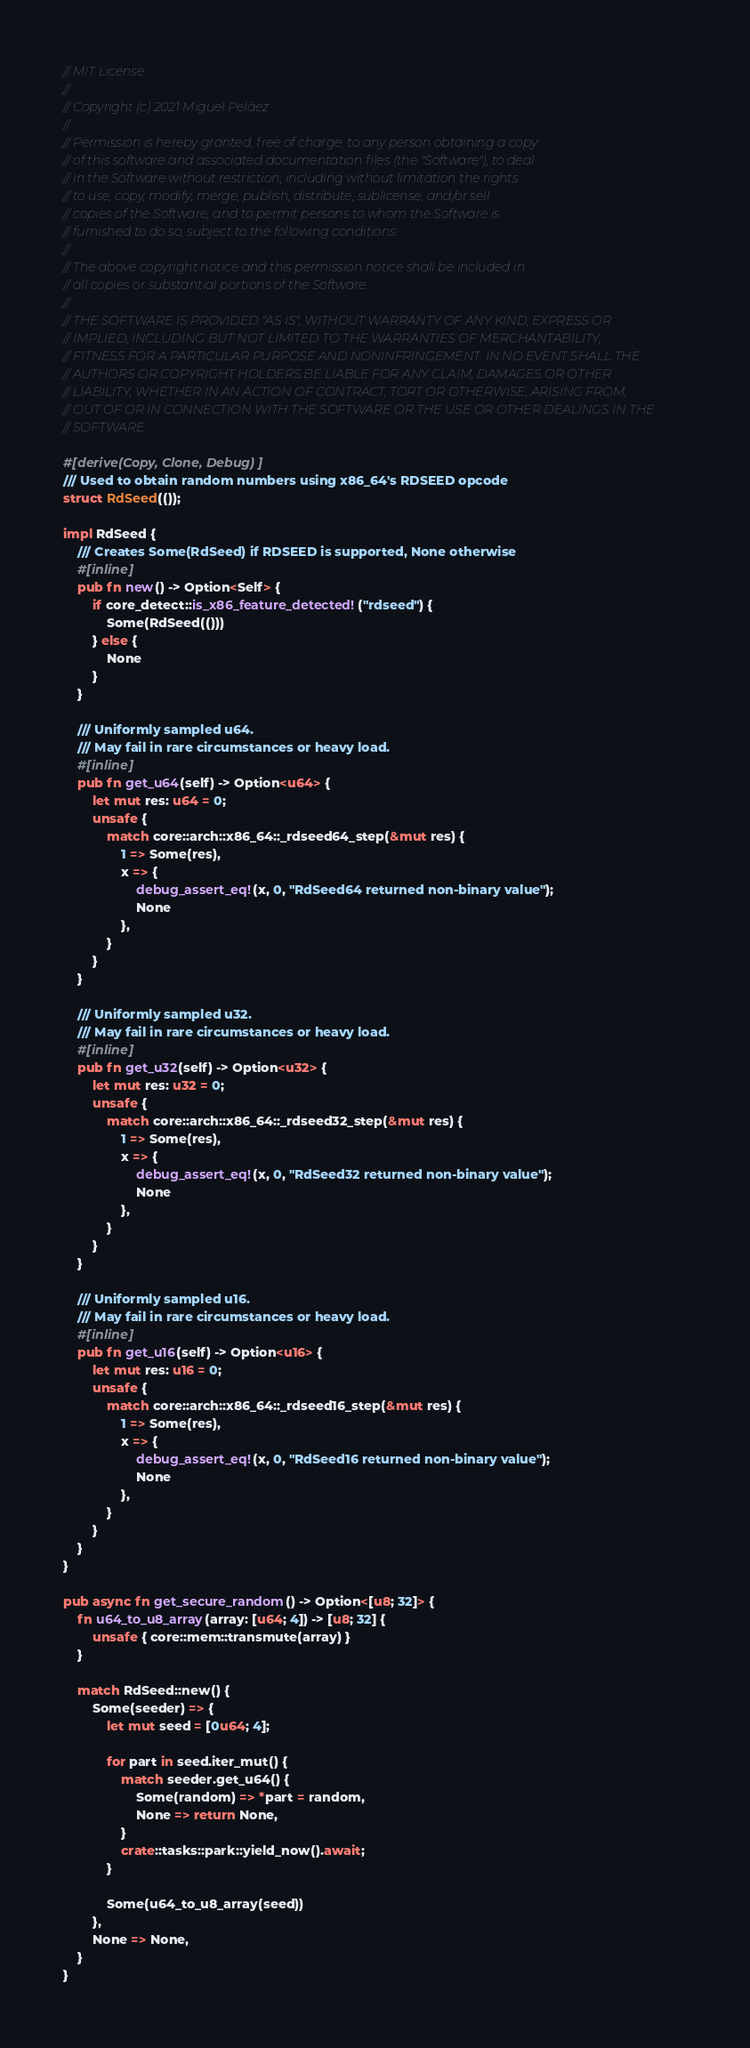<code> <loc_0><loc_0><loc_500><loc_500><_Rust_>// MIT License
//
// Copyright (c) 2021 Miguel Peláez
//
// Permission is hereby granted, free of charge, to any person obtaining a copy
// of this software and associated documentation files (the "Software"), to deal
// in the Software without restriction, including without limitation the rights
// to use, copy, modify, merge, publish, distribute, sublicense, and/or sell
// copies of the Software, and to permit persons to whom the Software is
// furnished to do so, subject to the following conditions:
//
// The above copyright notice and this permission notice shall be included in
// all copies or substantial portions of the Software.
//
// THE SOFTWARE IS PROVIDED "AS IS", WITHOUT WARRANTY OF ANY KIND, EXPRESS OR
// IMPLIED, INCLUDING BUT NOT LIMITED TO THE WARRANTIES OF MERCHANTABILITY,
// FITNESS FOR A PARTICULAR PURPOSE AND NONINFRINGEMENT. IN NO EVENT SHALL THE
// AUTHORS OR COPYRIGHT HOLDERS BE LIABLE FOR ANY CLAIM, DAMAGES OR OTHER
// LIABILITY, WHETHER IN AN ACTION OF CONTRACT, TORT OR OTHERWISE, ARISING FROM,
// OUT OF OR IN CONNECTION WITH THE SOFTWARE OR THE USE OR OTHER DEALINGS IN THE
// SOFTWARE.

#[derive(Copy, Clone, Debug)]
/// Used to obtain random numbers using x86_64's RDSEED opcode
struct RdSeed(());

impl RdSeed {
    /// Creates Some(RdSeed) if RDSEED is supported, None otherwise
    #[inline]
    pub fn new() -> Option<Self> {
        if core_detect::is_x86_feature_detected!("rdseed") {
            Some(RdSeed(()))
        } else {
            None
        }
    }

    /// Uniformly sampled u64.
    /// May fail in rare circumstances or heavy load.
    #[inline]
    pub fn get_u64(self) -> Option<u64> {
        let mut res: u64 = 0;
        unsafe {
            match core::arch::x86_64::_rdseed64_step(&mut res) {
                1 => Some(res),
                x => {
                    debug_assert_eq!(x, 0, "RdSeed64 returned non-binary value");
                    None
                },
            }
        }
    }

    /// Uniformly sampled u32.
    /// May fail in rare circumstances or heavy load.
    #[inline]
    pub fn get_u32(self) -> Option<u32> {
        let mut res: u32 = 0;
        unsafe {
            match core::arch::x86_64::_rdseed32_step(&mut res) {
                1 => Some(res),
                x => {
                    debug_assert_eq!(x, 0, "RdSeed32 returned non-binary value");
                    None
                },
            }
        }
    }

    /// Uniformly sampled u16.
    /// May fail in rare circumstances or heavy load.
    #[inline]
    pub fn get_u16(self) -> Option<u16> {
        let mut res: u16 = 0;
        unsafe {
            match core::arch::x86_64::_rdseed16_step(&mut res) {
                1 => Some(res),
                x => {
                    debug_assert_eq!(x, 0, "RdSeed16 returned non-binary value");
                    None
                },
            }
        }
    }
}

pub async fn get_secure_random() -> Option<[u8; 32]> {
    fn u64_to_u8_array(array: [u64; 4]) -> [u8; 32] {
        unsafe { core::mem::transmute(array) }
    }

    match RdSeed::new() {
        Some(seeder) => {
            let mut seed = [0u64; 4];

            for part in seed.iter_mut() {
                match seeder.get_u64() {
                    Some(random) => *part = random,
                    None => return None,
                }
                crate::tasks::park::yield_now().await;
            }

            Some(u64_to_u8_array(seed))
        },
        None => None,
    }
}
</code> 